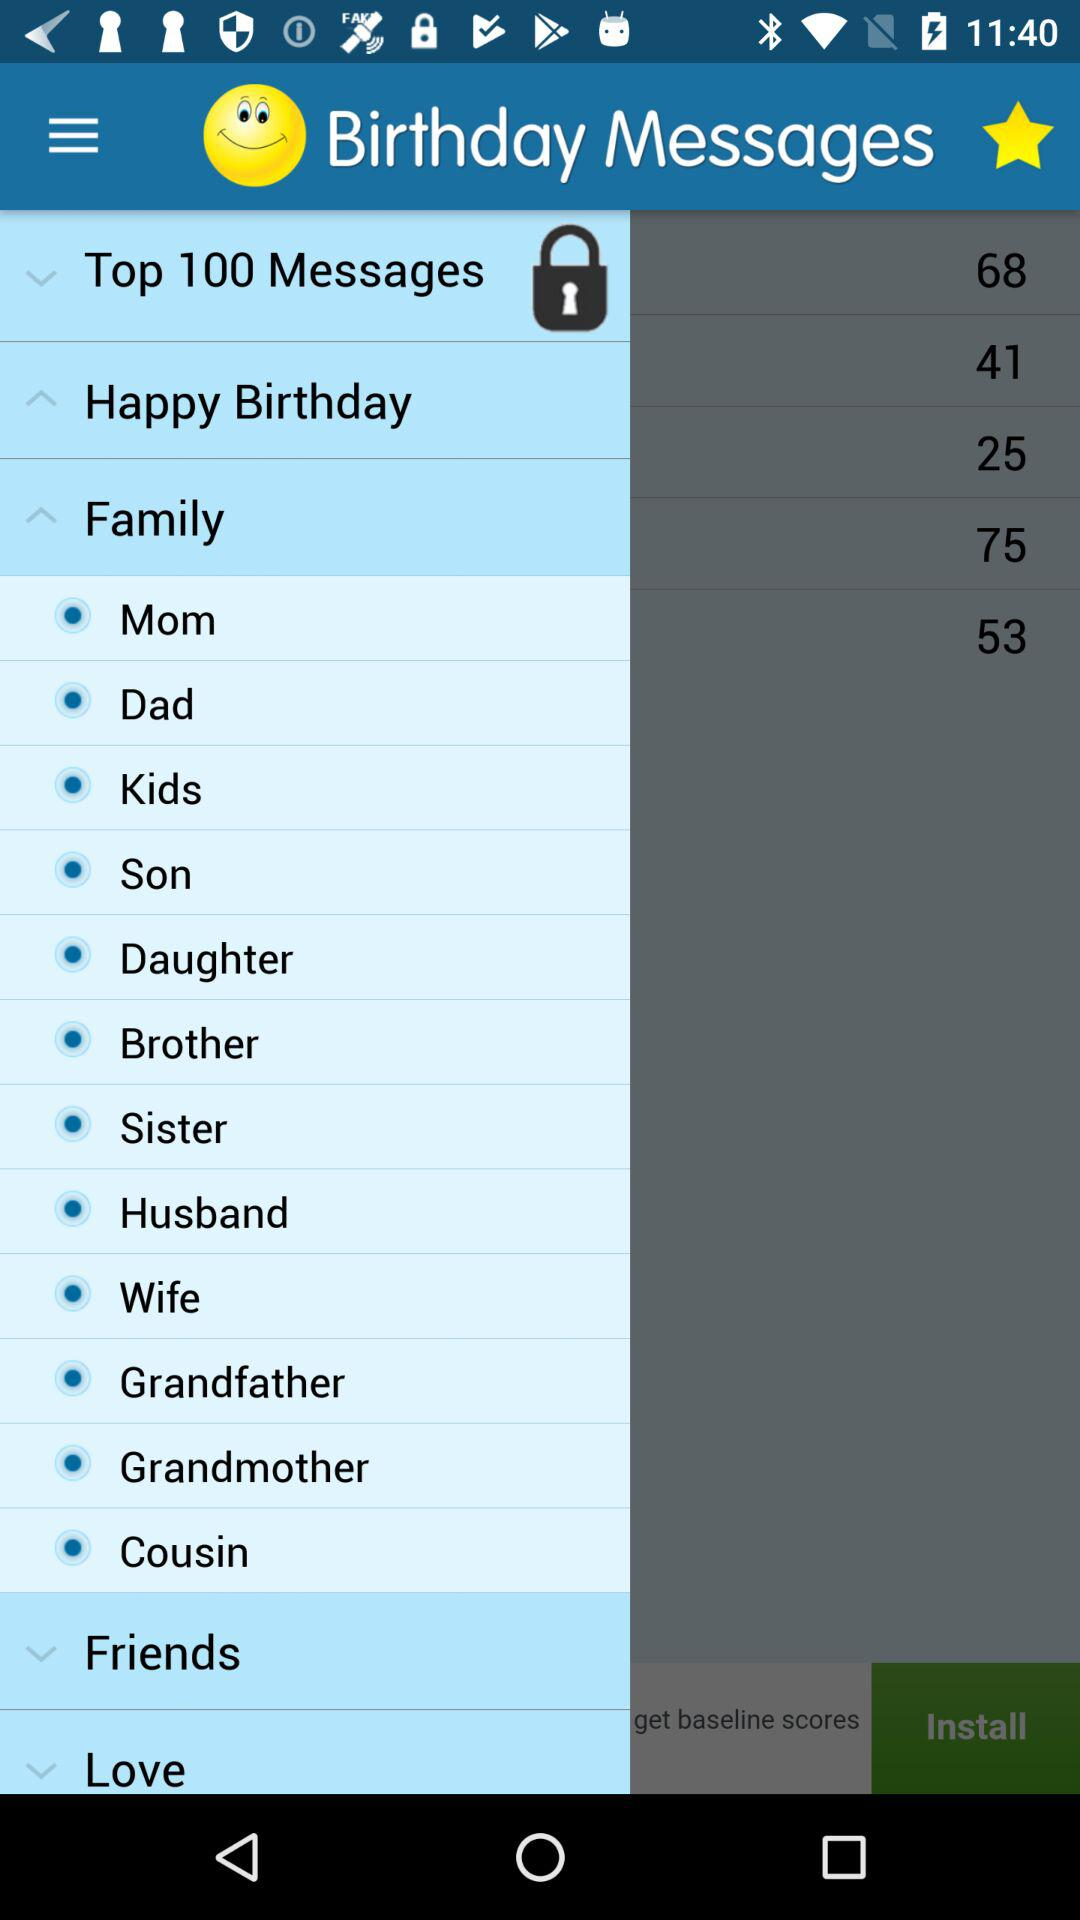Who are the people included in the family? The people are Mom, Dad, Kids, Son, Daughter, Brother, Sister, Husband, Wife, Grandfather, Grandmother and Cousin. 